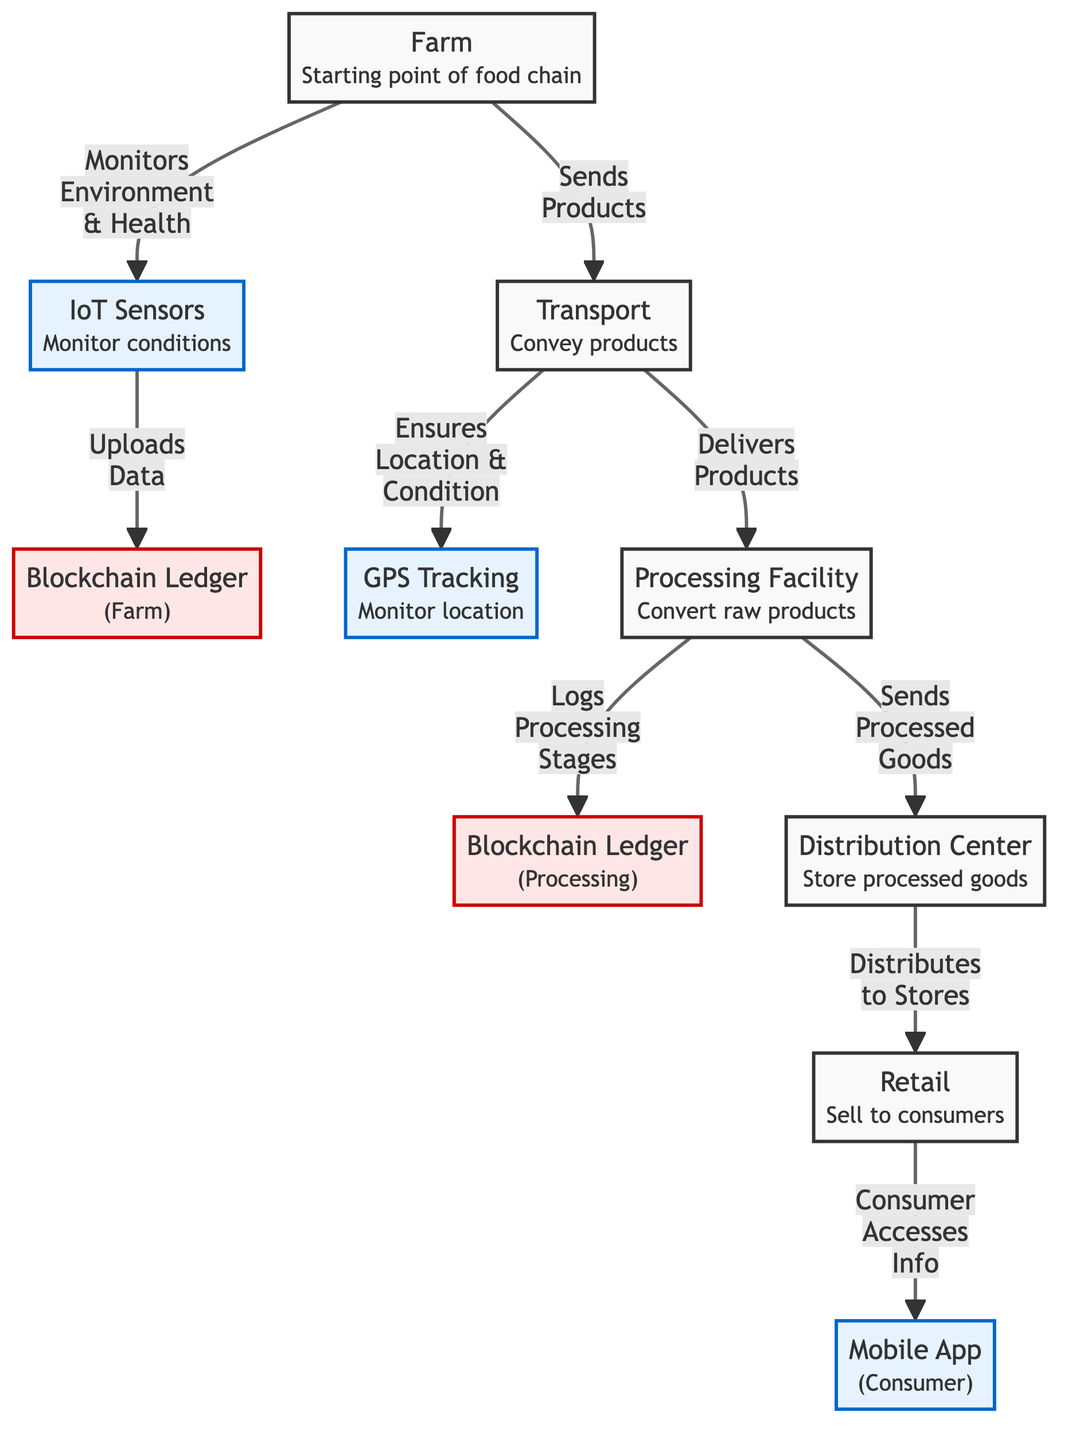What is the starting point of the food chain? The diagram shows "Farm" as the starting point of the food chain. It is the initial node where the food chain begins, depicted at the top of the flowchart.
Answer: Farm How many nodes are there in the diagram? Counting all the distinct elements in the flowchart, there are 9 nodes: Farm, IoT Sensors, Blockchain Ledger (Farm), Transport, GPS Tracking, Processing Facility, Blockchain Ledger (Processing), Distribution Center, and Retail.
Answer: 9 What role do IoT sensors play in the food chain? The IoT Sensors node indicates that it "Monitors Conditions" which suggests it is responsible for collecting data about environmental factors impacting farming.
Answer: Monitors Conditions Which node comes after "Transport" in the flowchart? According to the flowchart's arrow direction, "Transport" leads to two nodes: "GPS Tracking" and "Processing Facility". However, the first node after "Transport" is "GPS Tracking".
Answer: GPS Tracking How does the “Processing Facility” connect with the "Blockchain Ledger (Processing)"? The connection from "Processing Facility" to "Blockchain Ledger (Processing)" involves the flow labeled "Logs Processing Stages," indicating that the processing facility records its operational data in the blockchain ledger for transparency.
Answer: Logs Processing Stages How many tech nodes are present in the flowchart? The diagram identifies three nodes as tech nodes: IoT Sensors, GPS Tracking, and Mobile App. These nodes are highlighted with specific styling in the flowchart.
Answer: 3 What is the final consumer access point in the food chain? The last node in the flowchart represents “Mobile App," which allows consumers to access information about the food products sold at retail outlets, thus serving as the final point of access in the chain.
Answer: Mobile App Which node is responsible for converting raw products? In the flowchart, "Processing Facility" is designated as the node that "Converts raw products," indicating its role in transformation within the food chain.
Answer: Processing Facility What ensures the delivery of products to the processing facility? The arrow from "Transport" to "Processing Facility" indicates that "Transport" is responsible for delivering products, thus facilitating the supply chain transition between these two nodes.
Answer: Delivers Products 